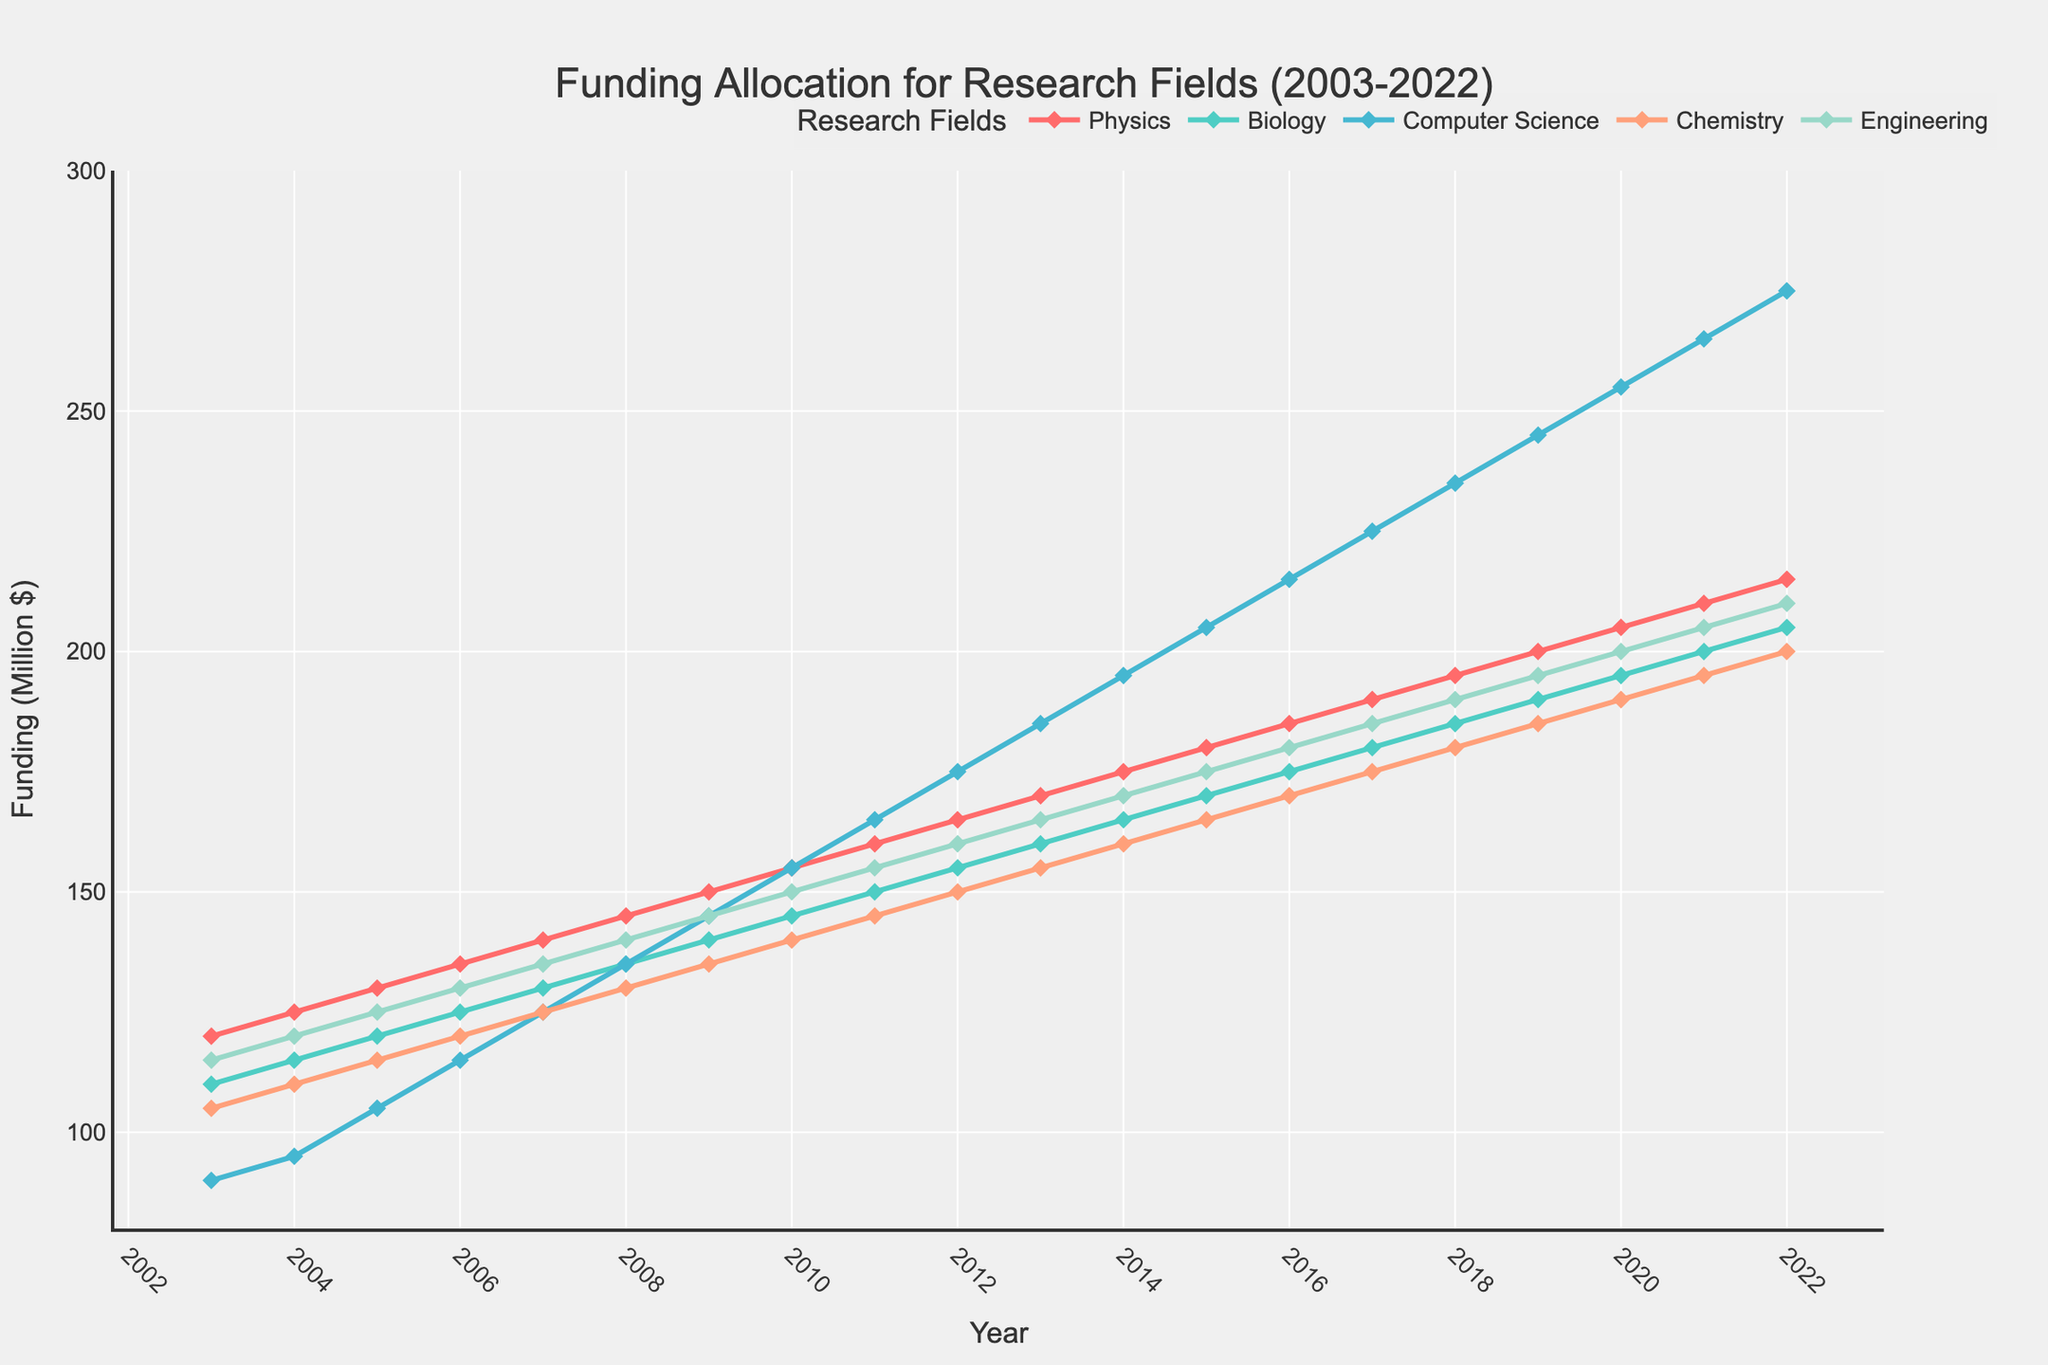What is the overall trend for funding in Computer Science from 2003 to 2022? From 2003 to 2022, the funding for Computer Science increases, as indicated by the upward slope of the line. It starts at 90 million dollars in 2003 and ends at 275 million dollars in 2022.
Answer: Increasing Which research field saw the highest funding in 2022? To determine which field got the highest funding in 2022, look at the data points for each line in 2022. Computer Science has the highest funding with 275 million dollars.
Answer: Computer Science What is the difference in funding between Biology and Engineering in 2018? In 2018, the funding for Biology can be found at one point, and for Engineering at another on the corresponding lines. Biology has 185 million dollars, and Engineering has 190 million dollars. The difference is 190 - 185 = 5 million dollars.
Answer: 5 million dollars In which year did Chemistry receive the same funding as Physics did in 2005? Looking at the line graph, in 2005, Physics funding is 130 million dollars. To find the same value on the Chemistry line, observe the intersection point which shows in 2014 Chemistry also received 130 million dollars.
Answer: 2014 How does the funding allocation for Physics in 2013 compare to Biology in 2020? From the figure, Physics in 2013 is at 170 million dollars and Biology in 2020 is at 195 million dollars. To compare, Biology's funding in 2020 is greater than Physics's funding in 2013.
Answer: Biology in 2020 is greater What is the average funding for Chemistry between 2010 and 2015? To find the average, sum the funding values for Chemistry from 2010 to 2015, which are 140, 145, 150, 155, 160, and 165 million dollars. Sum is 140+145+150+155+160+165 = 915, and average is 915/6 = 152.5 million dollars.
Answer: 152.5 million dollars Which research field had the steepest increase in funding between 2008 and 2018? By observing the slope of the lines between 2008 and 2018, Computer Science shows the steepest increase as the line rises sharply compared to others.
Answer: Computer Science What was the funding for Engineering in the year when it first surpassed 200 million dollars? By following the Engineering line, we observe that it first surpasses 200 million dollars in 2020.
Answer: 2020 How does the trend of funding in Biology from 2010 to 2015 compare to the trend in Engineering over the same period? The trend in Biology from 2010 to 2015 shows a steady increase. Similarly, Engineering also shows a steady increase. By comparing the slope of both lines, they both rise gradually without sharp changes.
Answer: Both show a steady increase 